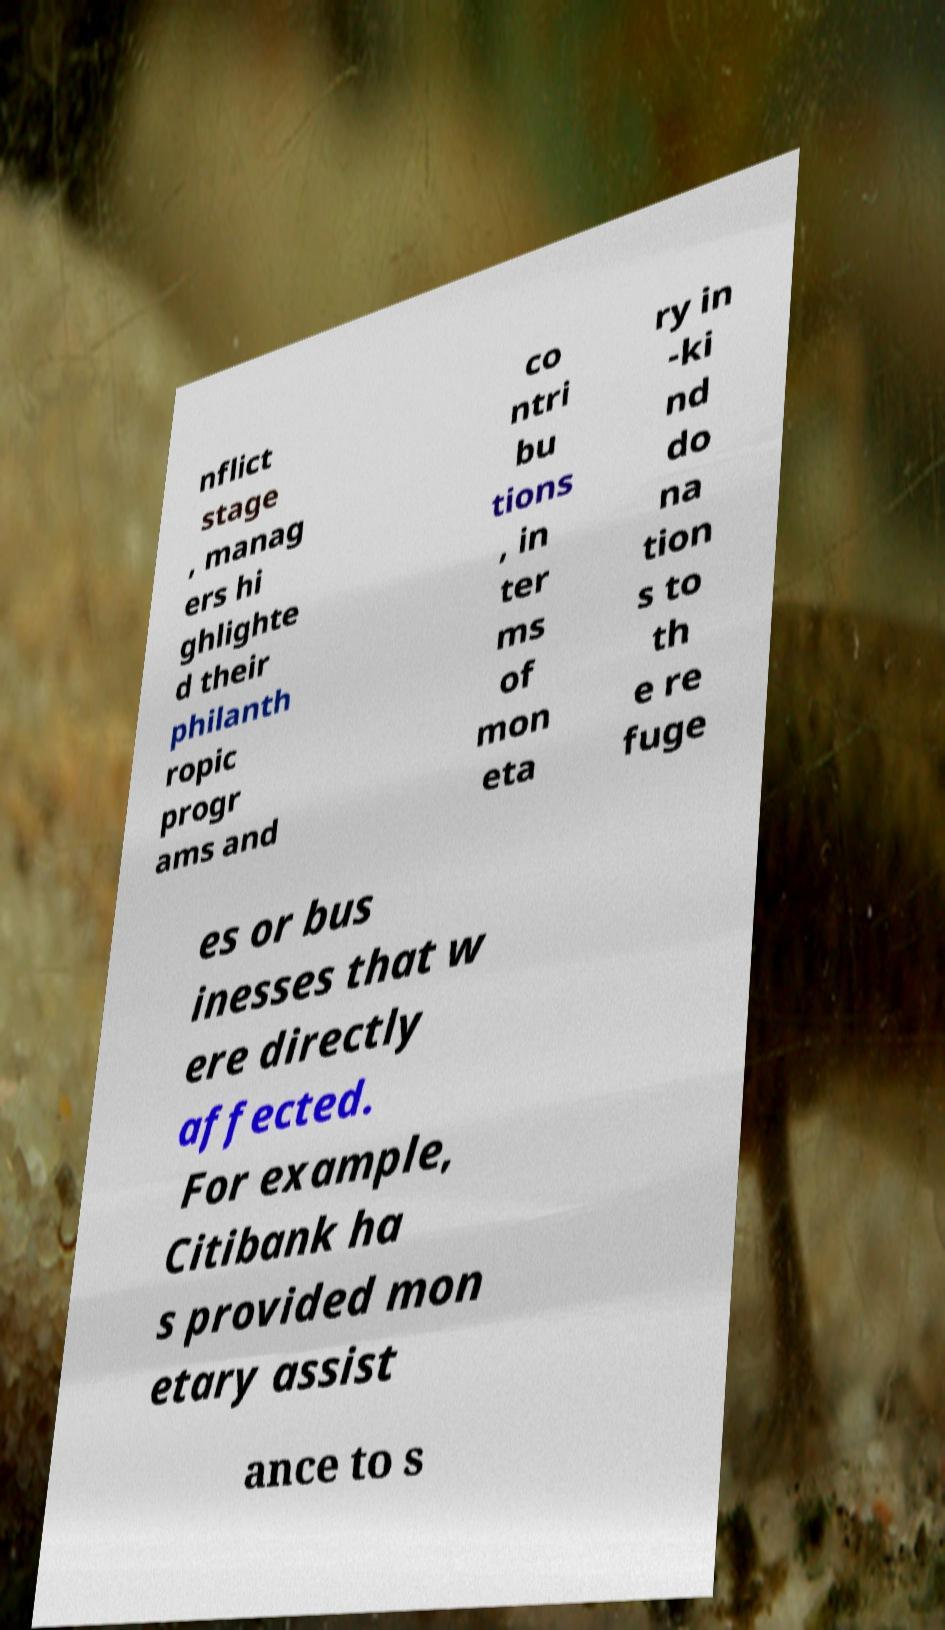What messages or text are displayed in this image? I need them in a readable, typed format. nflict stage , manag ers hi ghlighte d their philanth ropic progr ams and co ntri bu tions , in ter ms of mon eta ry in -ki nd do na tion s to th e re fuge es or bus inesses that w ere directly affected. For example, Citibank ha s provided mon etary assist ance to s 